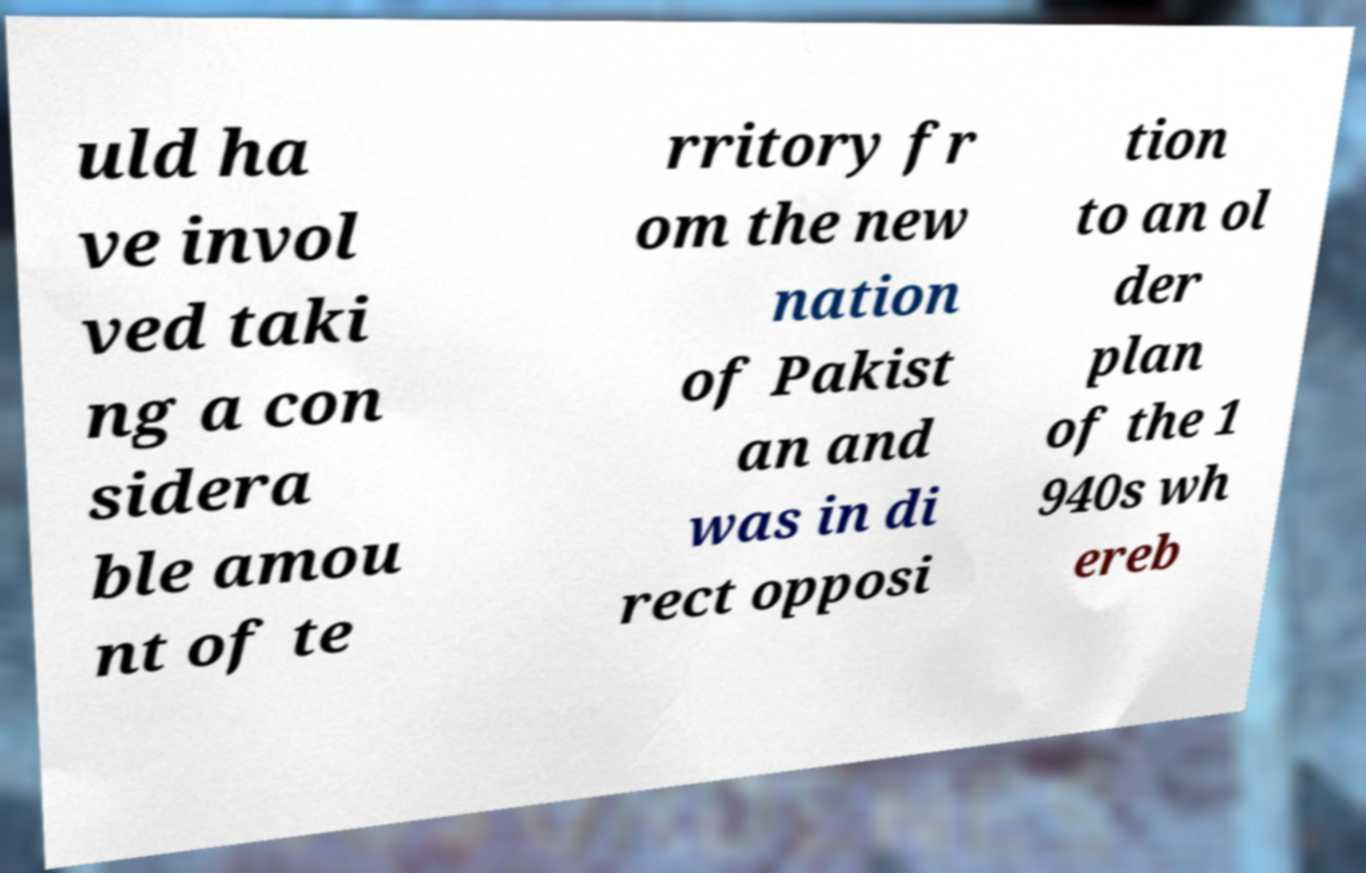Please read and relay the text visible in this image. What does it say? uld ha ve invol ved taki ng a con sidera ble amou nt of te rritory fr om the new nation of Pakist an and was in di rect opposi tion to an ol der plan of the 1 940s wh ereb 